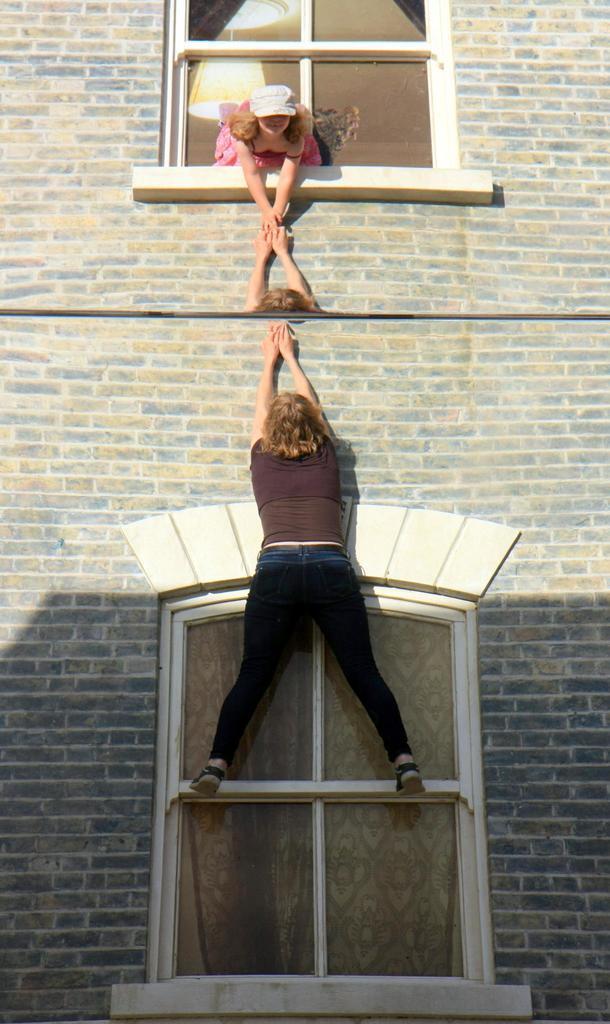In one or two sentences, can you explain what this image depicts? In this image I can see two people with different color dresses and one person is wearing the cap. I can see one person is standing on the window and another person is inside the window. These windows can be seen to the building. 